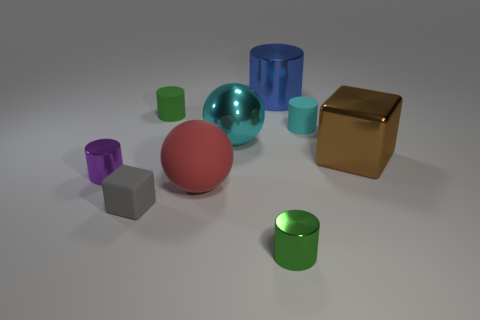Does the matte thing to the right of the green metallic cylinder have the same color as the big sphere behind the tiny purple shiny cylinder?
Provide a short and direct response. Yes. What number of other objects are there of the same shape as the tiny gray rubber thing?
Ensure brevity in your answer.  1. Are there the same number of shiny cylinders that are right of the green metal object and purple shiny cylinders that are behind the small purple cylinder?
Give a very brief answer. No. Is the material of the block on the left side of the brown thing the same as the block on the right side of the green metal cylinder?
Give a very brief answer. No. How many other things are there of the same size as the gray cube?
Provide a short and direct response. 4. How many things are either large red cylinders or small metallic cylinders behind the tiny green metallic cylinder?
Provide a succinct answer. 1. Is the number of big blue metallic things that are in front of the brown object the same as the number of tiny green balls?
Keep it short and to the point. Yes. What is the shape of the tiny cyan thing that is made of the same material as the red thing?
Provide a short and direct response. Cylinder. Are there any cylinders of the same color as the large shiny ball?
Keep it short and to the point. Yes. What number of shiny things are purple things or big cubes?
Provide a short and direct response. 2. 